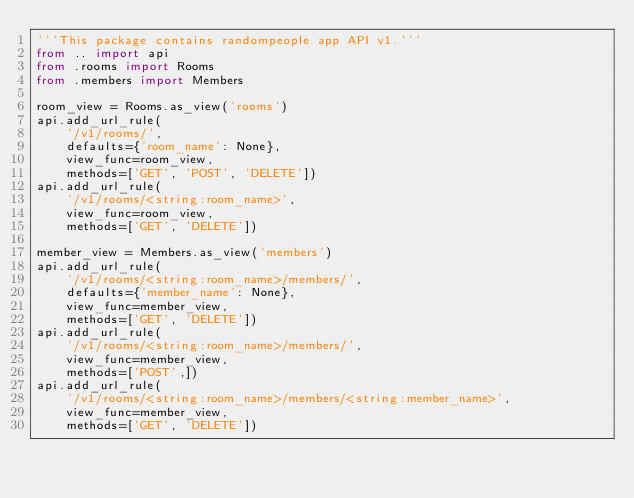Convert code to text. <code><loc_0><loc_0><loc_500><loc_500><_Python_>'''This package contains randompeople app API v1.'''
from .. import api
from .rooms import Rooms
from .members import Members

room_view = Rooms.as_view('rooms')
api.add_url_rule(
    '/v1/rooms/',
    defaults={'room_name': None},
    view_func=room_view,
    methods=['GET', 'POST', 'DELETE'])
api.add_url_rule(
    '/v1/rooms/<string:room_name>',
    view_func=room_view,
    methods=['GET', 'DELETE'])

member_view = Members.as_view('members')
api.add_url_rule(
    '/v1/rooms/<string:room_name>/members/',
    defaults={'member_name': None},
    view_func=member_view,
    methods=['GET', 'DELETE'])
api.add_url_rule(
    '/v1/rooms/<string:room_name>/members/',
    view_func=member_view,
    methods=['POST',])
api.add_url_rule(
    '/v1/rooms/<string:room_name>/members/<string:member_name>',
    view_func=member_view,
    methods=['GET', 'DELETE'])
</code> 